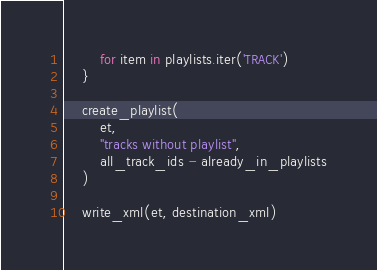<code> <loc_0><loc_0><loc_500><loc_500><_Python_>        for item in playlists.iter('TRACK')
    }

    create_playlist(
        et,
        "tracks without playlist",
        all_track_ids - already_in_playlists
    )

    write_xml(et, destination_xml)
</code> 